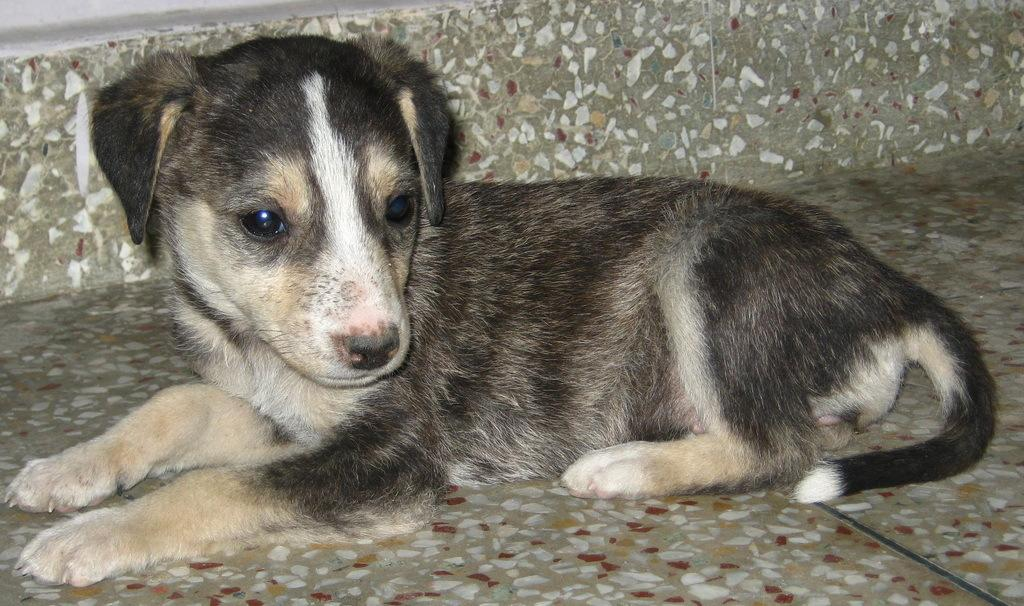What type of animal is in the image? There is a puppy in the image. Can you describe the color of the puppy? The puppy is black and light brown in color. What is the puppy doing in the image? The puppy is sitting on the floor. What authority does the puppy have in the image? The puppy does not have any authority in the image, as it is an animal and not a person or figure of authority. 